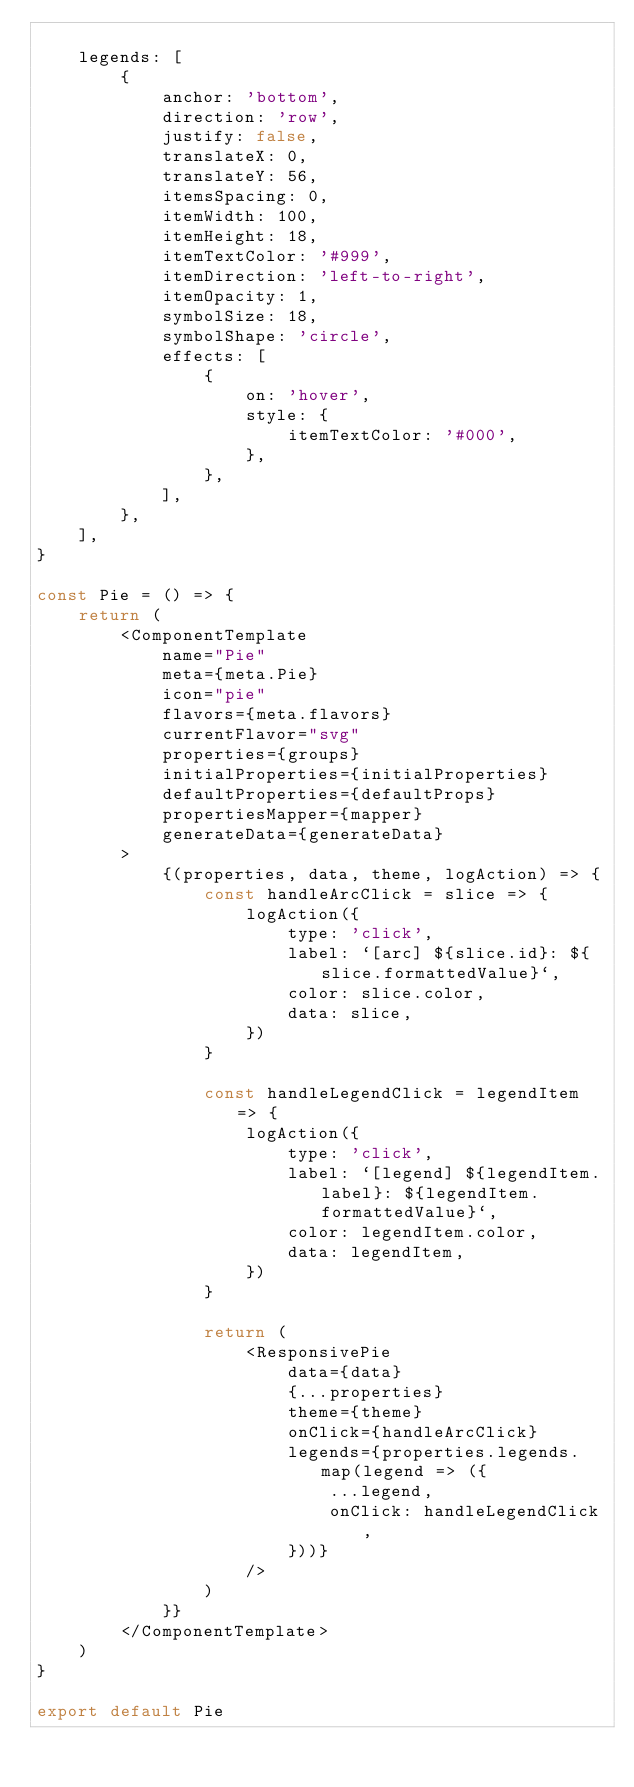Convert code to text. <code><loc_0><loc_0><loc_500><loc_500><_JavaScript_>
    legends: [
        {
            anchor: 'bottom',
            direction: 'row',
            justify: false,
            translateX: 0,
            translateY: 56,
            itemsSpacing: 0,
            itemWidth: 100,
            itemHeight: 18,
            itemTextColor: '#999',
            itemDirection: 'left-to-right',
            itemOpacity: 1,
            symbolSize: 18,
            symbolShape: 'circle',
            effects: [
                {
                    on: 'hover',
                    style: {
                        itemTextColor: '#000',
                    },
                },
            ],
        },
    ],
}

const Pie = () => {
    return (
        <ComponentTemplate
            name="Pie"
            meta={meta.Pie}
            icon="pie"
            flavors={meta.flavors}
            currentFlavor="svg"
            properties={groups}
            initialProperties={initialProperties}
            defaultProperties={defaultProps}
            propertiesMapper={mapper}
            generateData={generateData}
        >
            {(properties, data, theme, logAction) => {
                const handleArcClick = slice => {
                    logAction({
                        type: 'click',
                        label: `[arc] ${slice.id}: ${slice.formattedValue}`,
                        color: slice.color,
                        data: slice,
                    })
                }

                const handleLegendClick = legendItem => {
                    logAction({
                        type: 'click',
                        label: `[legend] ${legendItem.label}: ${legendItem.formattedValue}`,
                        color: legendItem.color,
                        data: legendItem,
                    })
                }

                return (
                    <ResponsivePie
                        data={data}
                        {...properties}
                        theme={theme}
                        onClick={handleArcClick}
                        legends={properties.legends.map(legend => ({
                            ...legend,
                            onClick: handleLegendClick,
                        }))}
                    />
                )
            }}
        </ComponentTemplate>
    )
}

export default Pie
</code> 